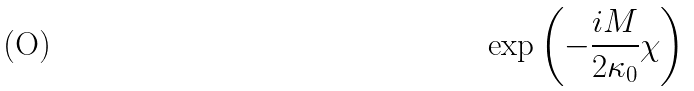Convert formula to latex. <formula><loc_0><loc_0><loc_500><loc_500>\exp \left ( - \frac { i M } { 2 \kappa _ { 0 } } \chi \right )</formula> 